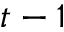<formula> <loc_0><loc_0><loc_500><loc_500>t - 1</formula> 